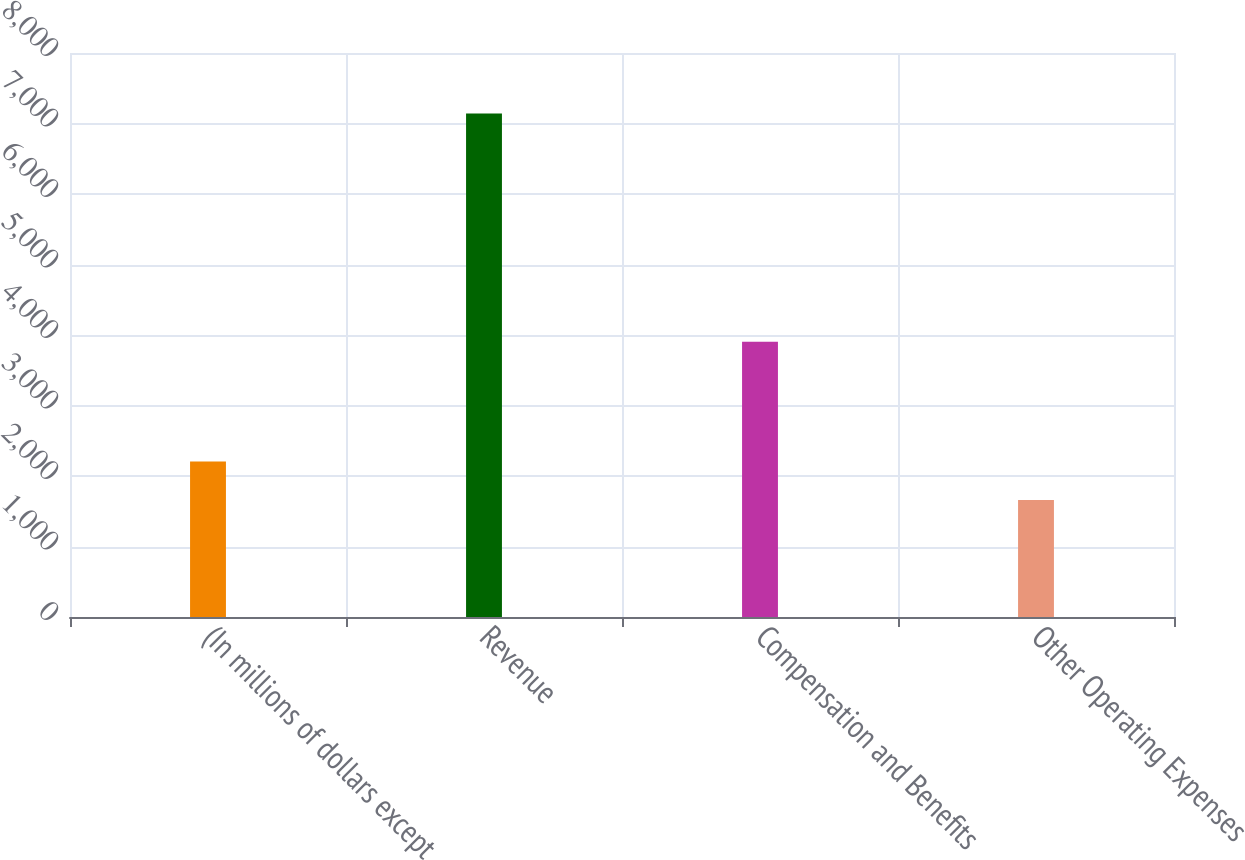Convert chart. <chart><loc_0><loc_0><loc_500><loc_500><bar_chart><fcel>(In millions of dollars except<fcel>Revenue<fcel>Compensation and Benefits<fcel>Other Operating Expenses<nl><fcel>2206.5<fcel>7143<fcel>3904<fcel>1658<nl></chart> 